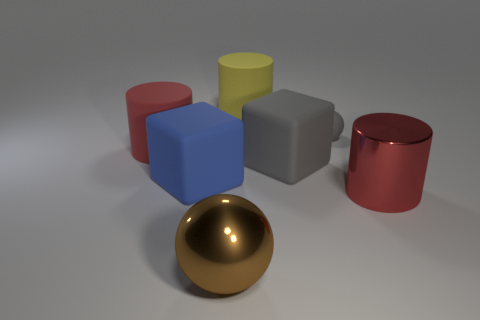Add 2 red rubber objects. How many objects exist? 9 Subtract all cubes. How many objects are left? 5 Add 5 big brown cylinders. How many big brown cylinders exist? 5 Subtract 1 gray balls. How many objects are left? 6 Subtract all brown metallic cubes. Subtract all red matte things. How many objects are left? 6 Add 2 blue rubber things. How many blue rubber things are left? 3 